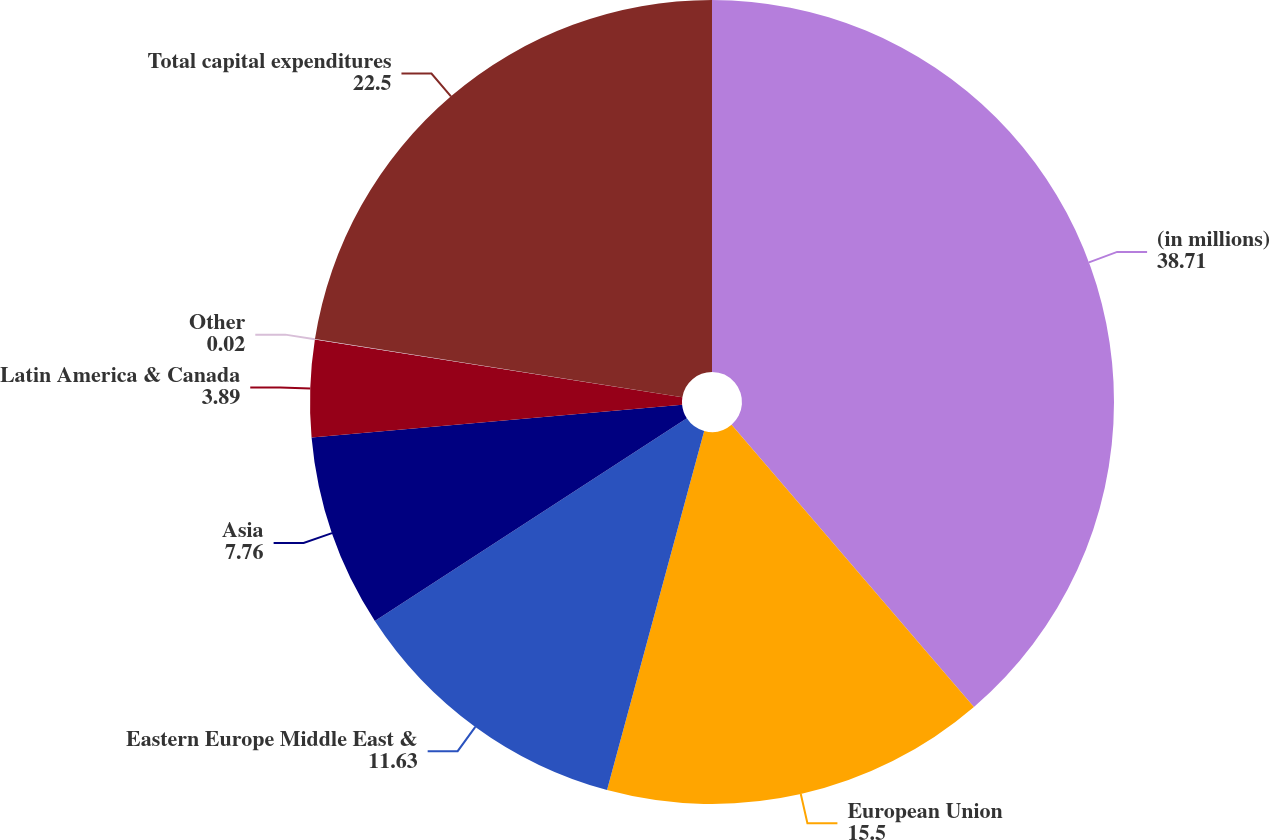Convert chart. <chart><loc_0><loc_0><loc_500><loc_500><pie_chart><fcel>(in millions)<fcel>European Union<fcel>Eastern Europe Middle East &<fcel>Asia<fcel>Latin America & Canada<fcel>Other<fcel>Total capital expenditures<nl><fcel>38.71%<fcel>15.5%<fcel>11.63%<fcel>7.76%<fcel>3.89%<fcel>0.02%<fcel>22.5%<nl></chart> 